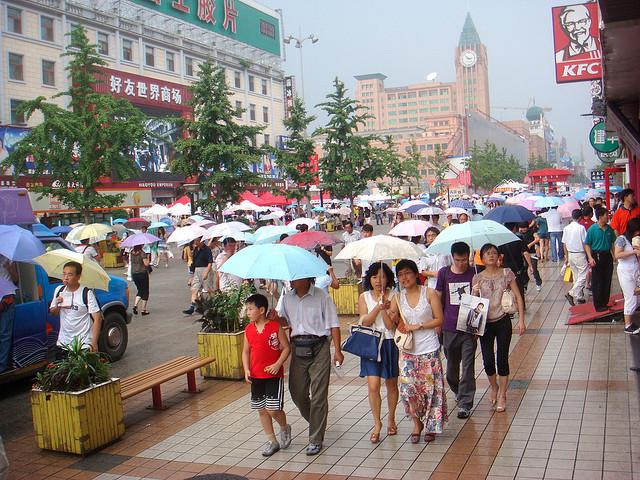Do you see a clock?
Concise answer only. Yes. Do you think this is a big city?
Concise answer only. Yes. Is it actually raining?
Be succinct. No. 